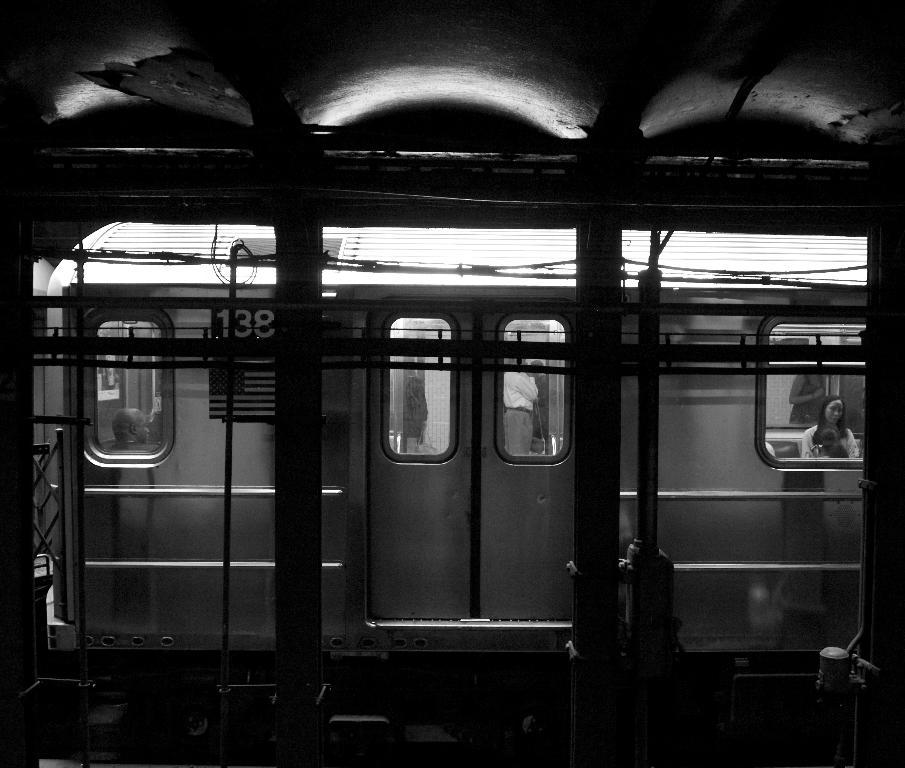What is the main subject in the middle of the image? There is a train in the middle of the image. What is located near the train? There is a platform in the image. What type of architectural feature can be seen in the image? Pillars are present in the image. What is visible at the top of the image? There is a roof visible at the top of the image. Where is the faucet located in the image? There is no faucet present in the image. How many family members can be seen in the image? There is no family or family members present in the image. 